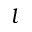Convert formula to latex. <formula><loc_0><loc_0><loc_500><loc_500>l</formula> 